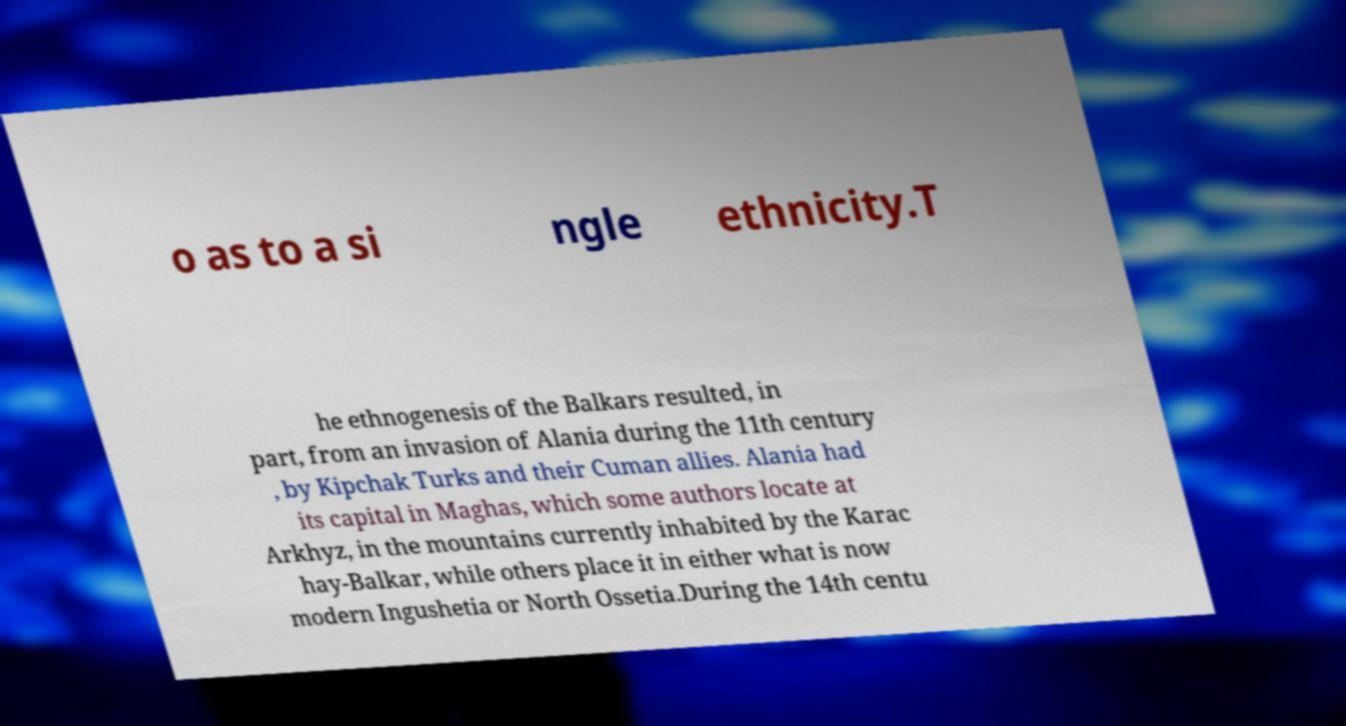For documentation purposes, I need the text within this image transcribed. Could you provide that? o as to a si ngle ethnicity.T he ethnogenesis of the Balkars resulted, in part, from an invasion of Alania during the 11th century , by Kipchak Turks and their Cuman allies. Alania had its capital in Maghas, which some authors locate at Arkhyz, in the mountains currently inhabited by the Karac hay-Balkar, while others place it in either what is now modern Ingushetia or North Ossetia.During the 14th centu 